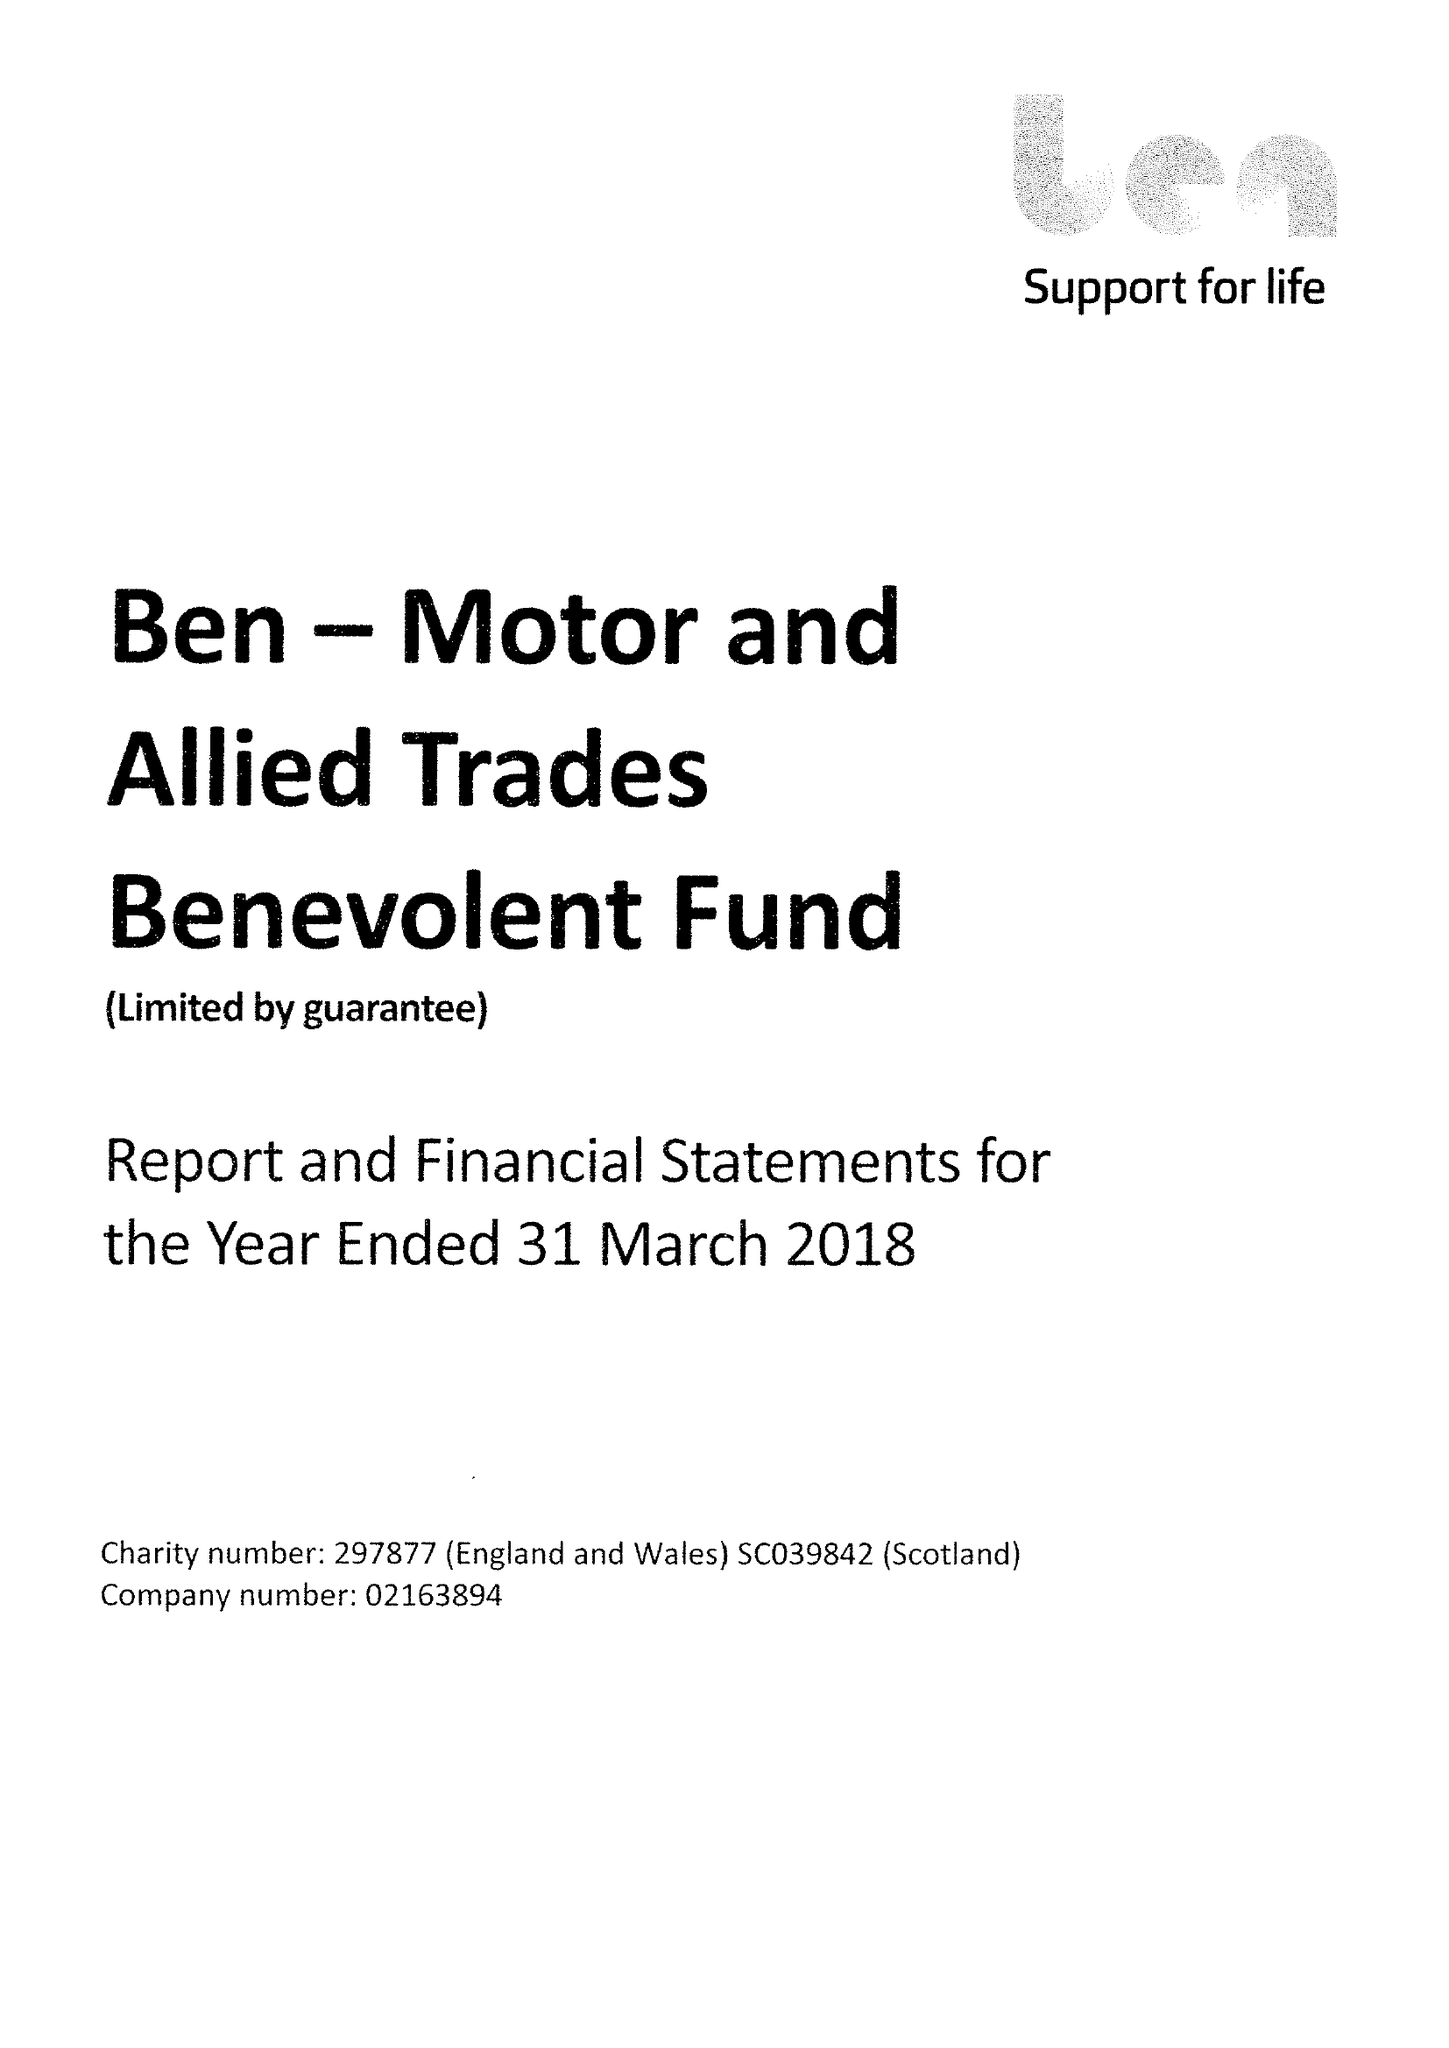What is the value for the report_date?
Answer the question using a single word or phrase. 2018-03-31 